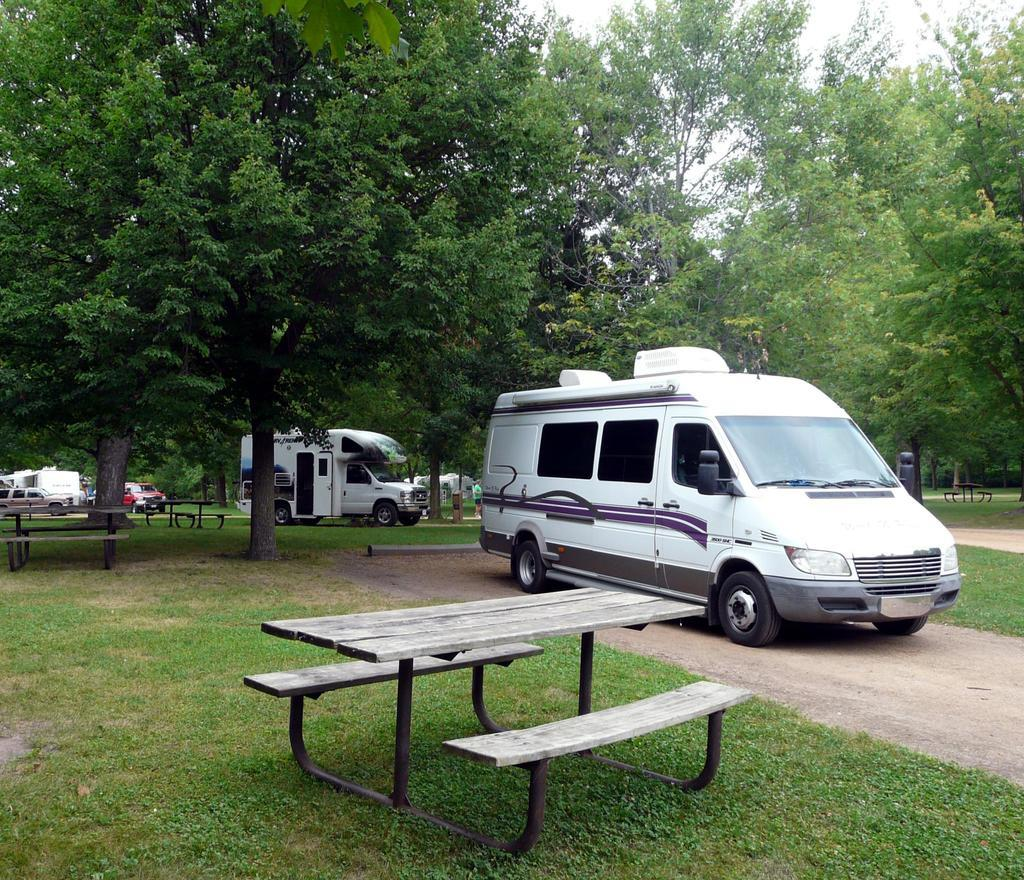What type of outdoor furniture is present in the image? There is a bench in the grass in the image. What else can be seen in the image besides the bench? There are vehicles and trees in the image. How many rings are visible on the bench in the image? There are no rings present on the bench or in the image. 